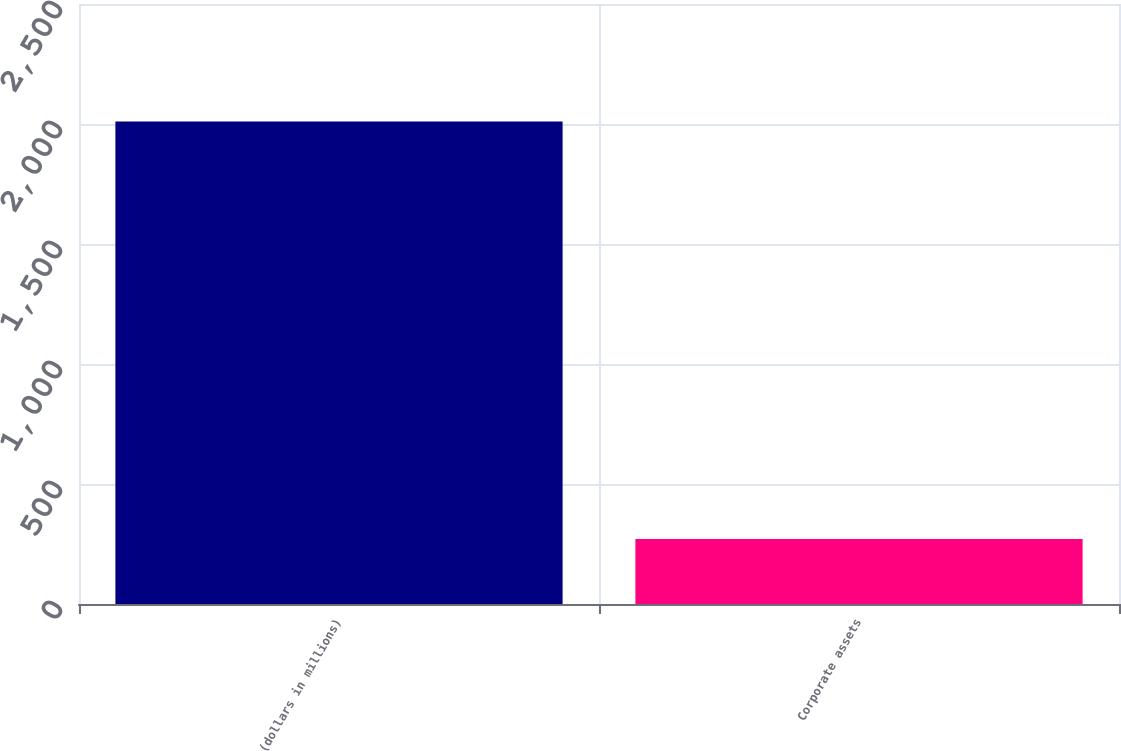Convert chart. <chart><loc_0><loc_0><loc_500><loc_500><bar_chart><fcel>(dollars in millions)<fcel>Corporate assets<nl><fcel>2010<fcel>271<nl></chart> 